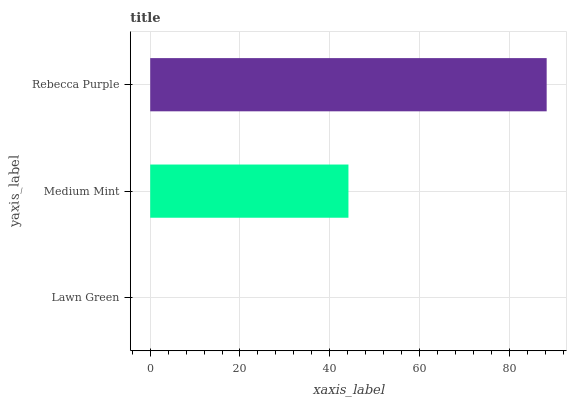Is Lawn Green the minimum?
Answer yes or no. Yes. Is Rebecca Purple the maximum?
Answer yes or no. Yes. Is Medium Mint the minimum?
Answer yes or no. No. Is Medium Mint the maximum?
Answer yes or no. No. Is Medium Mint greater than Lawn Green?
Answer yes or no. Yes. Is Lawn Green less than Medium Mint?
Answer yes or no. Yes. Is Lawn Green greater than Medium Mint?
Answer yes or no. No. Is Medium Mint less than Lawn Green?
Answer yes or no. No. Is Medium Mint the high median?
Answer yes or no. Yes. Is Medium Mint the low median?
Answer yes or no. Yes. Is Rebecca Purple the high median?
Answer yes or no. No. Is Rebecca Purple the low median?
Answer yes or no. No. 